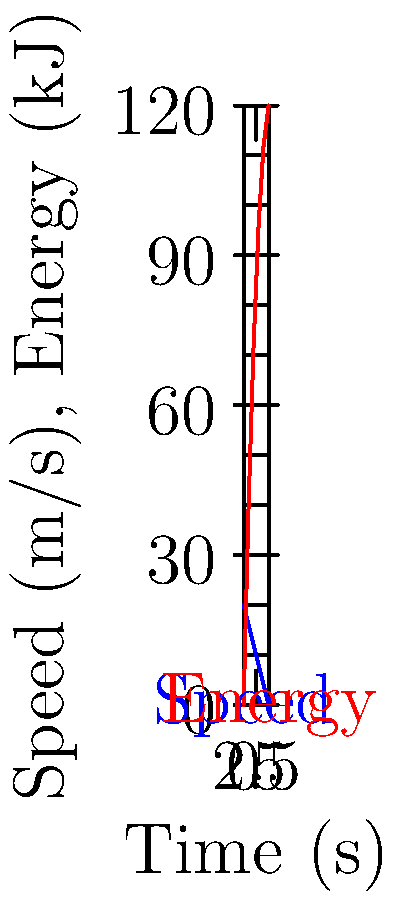Based on the graph showing the relationship between vehicle speed and energy recovered during regenerative braking, what is the average rate of energy recovery in kJ/s over the 5-second braking period? To find the average rate of energy recovery, we need to follow these steps:

1. Determine the total energy recovered:
   From the graph, we can see that the total energy recovered at t = 5s is 120 kJ.

2. Calculate the time period:
   The braking period is from t = 0s to t = 5s, so the total time is 5 seconds.

3. Calculate the average rate of energy recovery:
   Average rate = Total energy recovered / Time period
   $$ \text{Average rate} = \frac{120 \text{ kJ}}{5 \text{ s}} = 24 \text{ kJ/s} $$

Therefore, the average rate of energy recovery during the 5-second braking period is 24 kJ/s.
Answer: 24 kJ/s 